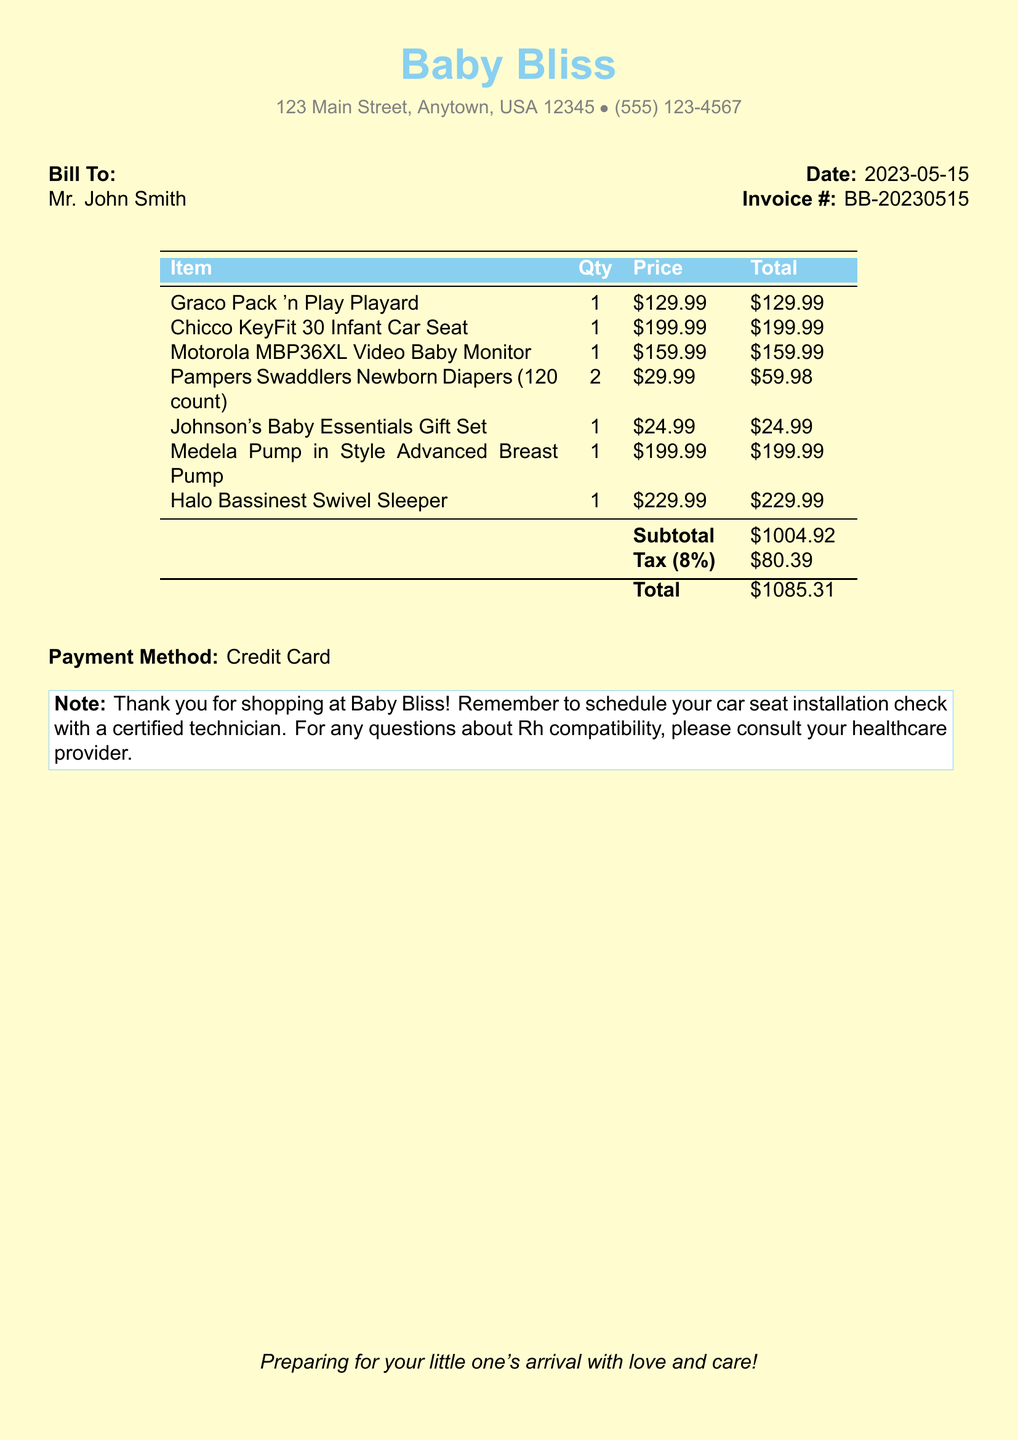What is the date of the bill? The date of the bill is specified in the document under the "Date" section.
Answer: 2023-05-15 Who is the bill addressed to? The "Bill To" section identifies the recipient of the bill.
Answer: Mr. John Smith What is the total amount due? The total amount due is listed at the bottom under the "Total" section of the table.
Answer: $1085.31 How many packs of Pampers Swaddlers were purchased? The quantity of Pampers Swaddlers is noted in the "Qty" column of the table.
Answer: 2 What is the price of the Chicco KeyFit 30 Infant Car Seat? The price of the Chicco KeyFit is given in the "Price" column next to that item.
Answer: $199.99 What was the subtotal before tax? The subtotal is summarized in the table before the tax is added.
Answer: $1004.92 What payment method was used? The document explicitly states the payment method used for the transaction.
Answer: Credit Card What is the store's name? The store's name is prominently displayed at the top of the document.
Answer: Baby Bliss How much was paid in tax? The tax amount can be found in the summary section of the document.
Answer: $80.39 